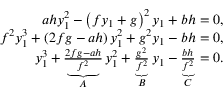<formula> <loc_0><loc_0><loc_500><loc_500>\begin{array} { r } { a h y _ { 1 } ^ { 2 } - \left ( f y _ { 1 } + g \right ) ^ { 2 } y _ { 1 } + b h = 0 , } \\ { f ^ { 2 } y _ { 1 } ^ { 3 } + \left ( 2 f g - a h \right ) y _ { 1 } ^ { 2 } + g ^ { 2 } y _ { 1 } - b h = 0 , } \\ { y _ { 1 } ^ { 3 } + \underbrace { \frac { 2 f g - a h } { f ^ { 2 } } } _ { A } y _ { 1 } ^ { 2 } + \underbrace { \frac { g ^ { 2 } } { f ^ { 2 } } } _ { B } y _ { 1 } - \underbrace { \frac { b h } { f ^ { 2 } } } _ { C } = 0 . } \end{array}</formula> 